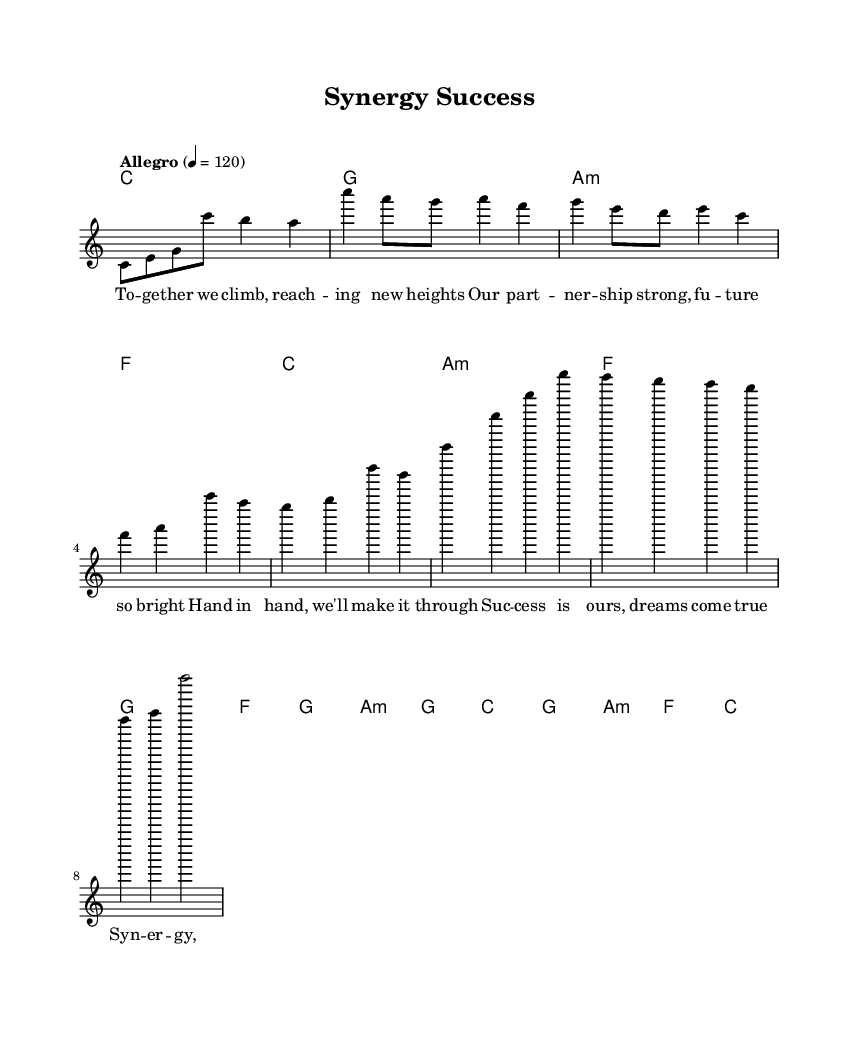What is the key signature of this music? The key signature is C major, which has no sharps or flats indicated on the staff.
Answer: C major What is the time signature of this music? The time signature is indicated at the beginning of the score as 4/4, meaning there are four beats per measure and the quarter note gets one beat.
Answer: 4/4 What is the tempo marking of the piece? The tempo marking is stated as "Allegro" with a metronome marking of 120 beats per minute, indicating a fast and lively pace for the piece.
Answer: Allegro, 120 How many measures are in the chorus section? The chorus section consists of four measures, as indicated by the grouping of notes and rests within that section.
Answer: 4 What is the first lyric line in the verse? The first lyric line in the verse is "Together we climb, reaching new heights", which sets the theme of teamwork and partnership.
Answer: Together we climb, reaching new heights Which chord precedes the pre-chorus? The chord preceding the pre-chorus is F major, as noted in the harmonies section right before this section of the lyrics starts.
Answer: F What message is conveyed in the chorus? The chorus conveys a message of synergy and teamwork being vital for success, emphasizing that together they are unstoppable.
Answer: Synergy, it's our key to victory 